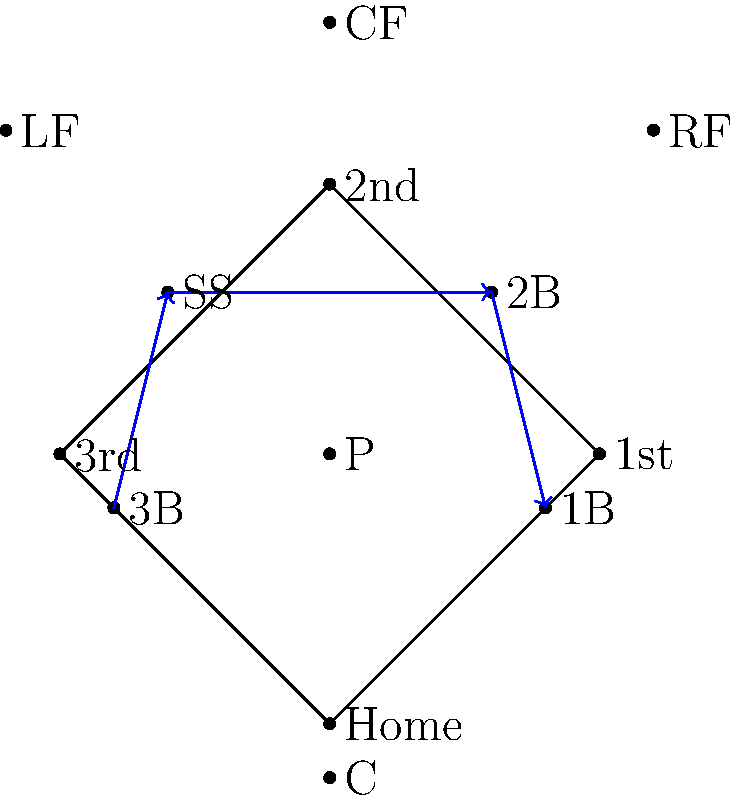In a softball game, your team is facing a right-handed batter known for hitting ground balls to the left side of the infield. As the defensive captain, how should you adjust your team's positioning to optimize defensive coverage? To optimize defensive coverage against a right-handed batter who tends to hit ground balls to the left side of the infield, we should consider the following steps:

1. Recognize the batter's tendency: Right-handed batters who hit ground balls to the left side are likely to pull the ball between third base and shortstop.

2. Shift the infield: 
   a. Move the shortstop (SS) slightly towards third base.
   b. Shift the second baseman (2B) towards second base to cover more of the middle infield.
   c. The third baseman (3B) should play closer to the foul line to cover any hard-hit balls down the line.

3. Adjust the outfield:
   a. Shift the left fielder (LF) slightly towards the foul line.
   b. Move the center fielder (CF) a bit towards left-center.
   c. The right fielder (RF) can play slightly shallower and towards right-center.

4. First base (1B) coverage:
   a. The first baseman should play closer to the bag to be ready for throws from the left side of the infield.

5. Catcher (C) and Pitcher (P):
   a. These positions remain relatively unchanged, but the catcher should be prepared for more plays at first base.

This defensive shift creates a stronger presence on the left side of the field while maintaining coverage across the entire playing area. It increases the chances of fielding ground balls hit to the left side while still allowing for quick adjustments if the batter hits against the shift.
Answer: Shift infield left, move outfield slightly left, keep 1B near bag 